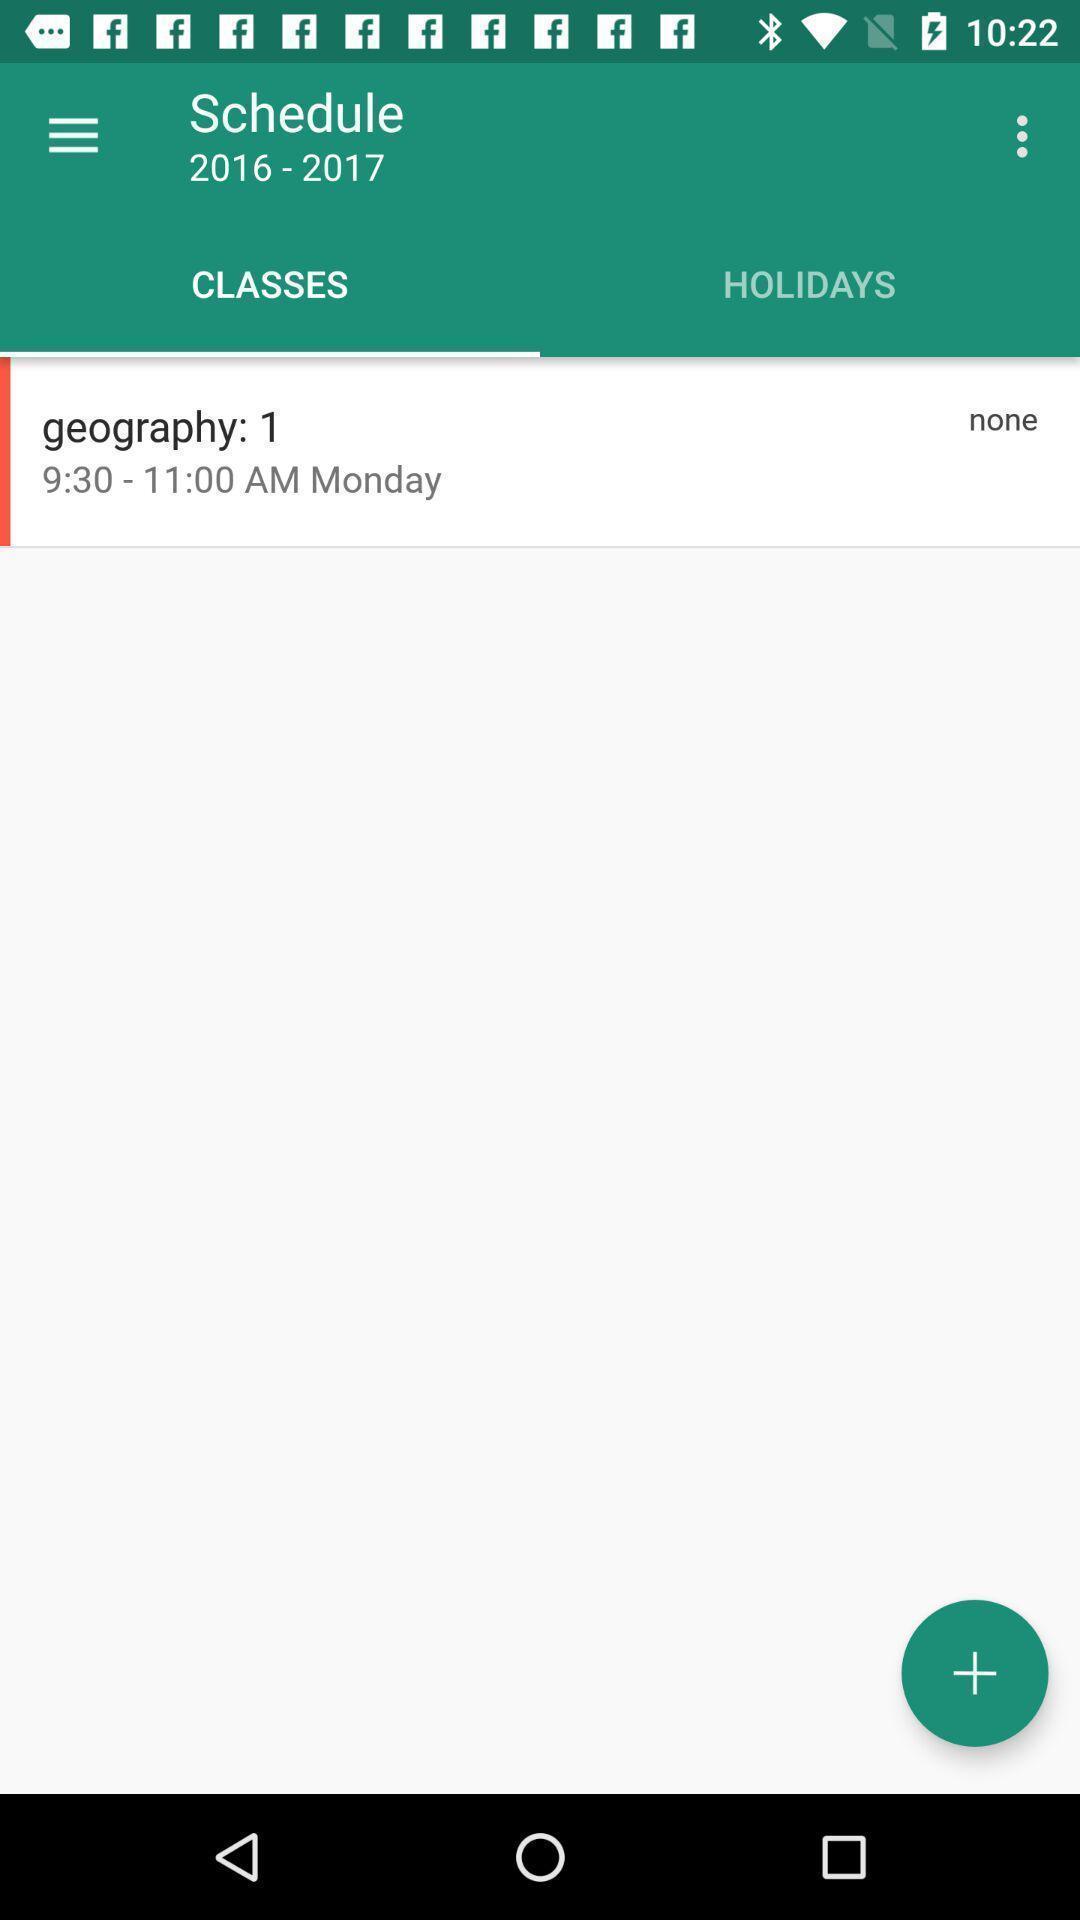Provide a detailed account of this screenshot. Students setting an schedule for their day. 